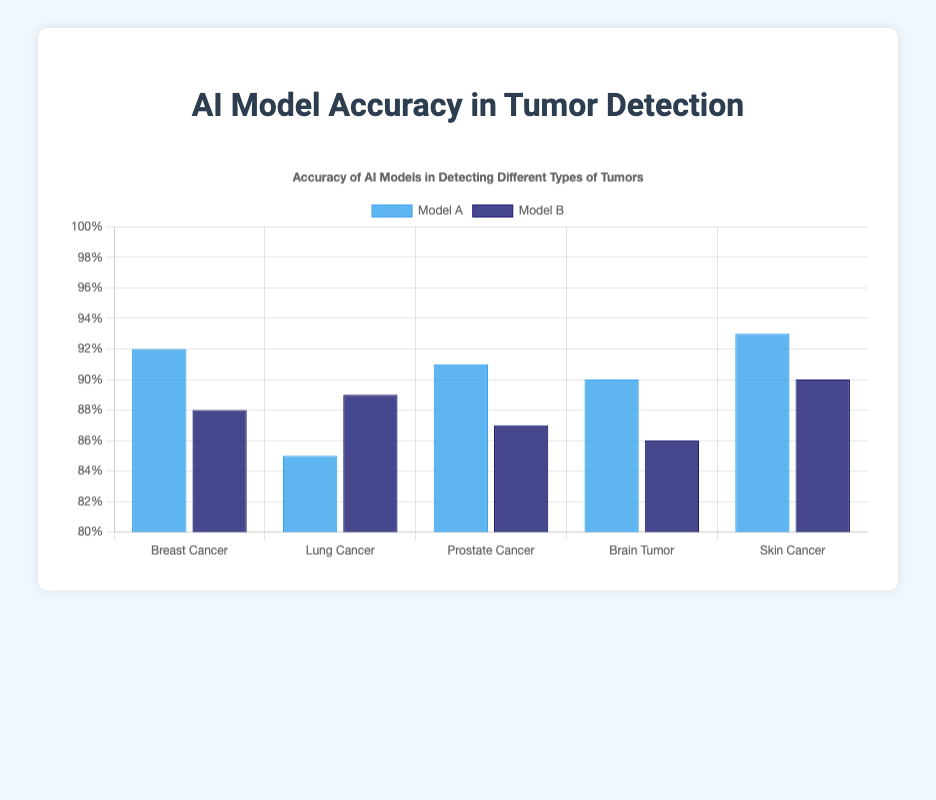What is the average accuracy of Model A across all tumor types? To find the average accuracy of Model A, sum all the accuracies for Model A and divide by the number of tumor types. The accuracies are: 0.92 + 0.85 + 0.91 + 0.90 + 0.93 = 4.51. There are 5 tumor types, so the average is 4.51 / 5 = 0.902.
Answer: 0.902 Which model performs better in detecting Lung Cancer? Compare the accuracy values of Model A and Model B for Lung Cancer. Model A has an accuracy of 0.85 while Model B has 0.89. Since 0.89 is greater than 0.85, Model B performs better in detecting Lung Cancer.
Answer: Model B For which tumor type is the difference in accuracy between Model A and Model B the largest? To determine this, calculate the differences for each tumor type: Breast Cancer: 0.92 - 0.88 = 0.04; Lung Cancer: 0.89 - 0.85 = 0.04; Prostate Cancer: 0.91 - 0.87 = 0.04; Brain Tumor: 0.90 - 0.86 = 0.04; Skin Cancer: 0.93 - 0.90 = 0.03. The largest difference is for Breast Cancer, Lung Cancer, Prostate Cancer, and Brain Tumor, each with a difference of 0.04.
Answer: Breast Cancer, Lung Cancer, Prostate Cancer, Brain Tumor Which tumor type has the highest accuracy for Model A? Look at the accuracy values for Model A across all tumor types: Breast Cancer (0.92), Lung Cancer (0.85), Prostate Cancer (0.91), Brain Tumor (0.90), Skin Cancer (0.93). The highest accuracy is for Skin Cancer at 0.93.
Answer: Skin Cancer What is the overall difference in accuracy between Model A and Model B for all tumor types? Calculate the total accuracy for both models and then find the difference. Total accuracy for Model A is 0.92 + 0.85 + 0.91 + 0.90 + 0.93 = 4.51. Total accuracy for Model B is 0.88 + 0.89 + 0.87 + 0.86 + 0.90 = 4.40. The overall difference is 4.51 - 4.40 = 0.11.
Answer: 0.11 